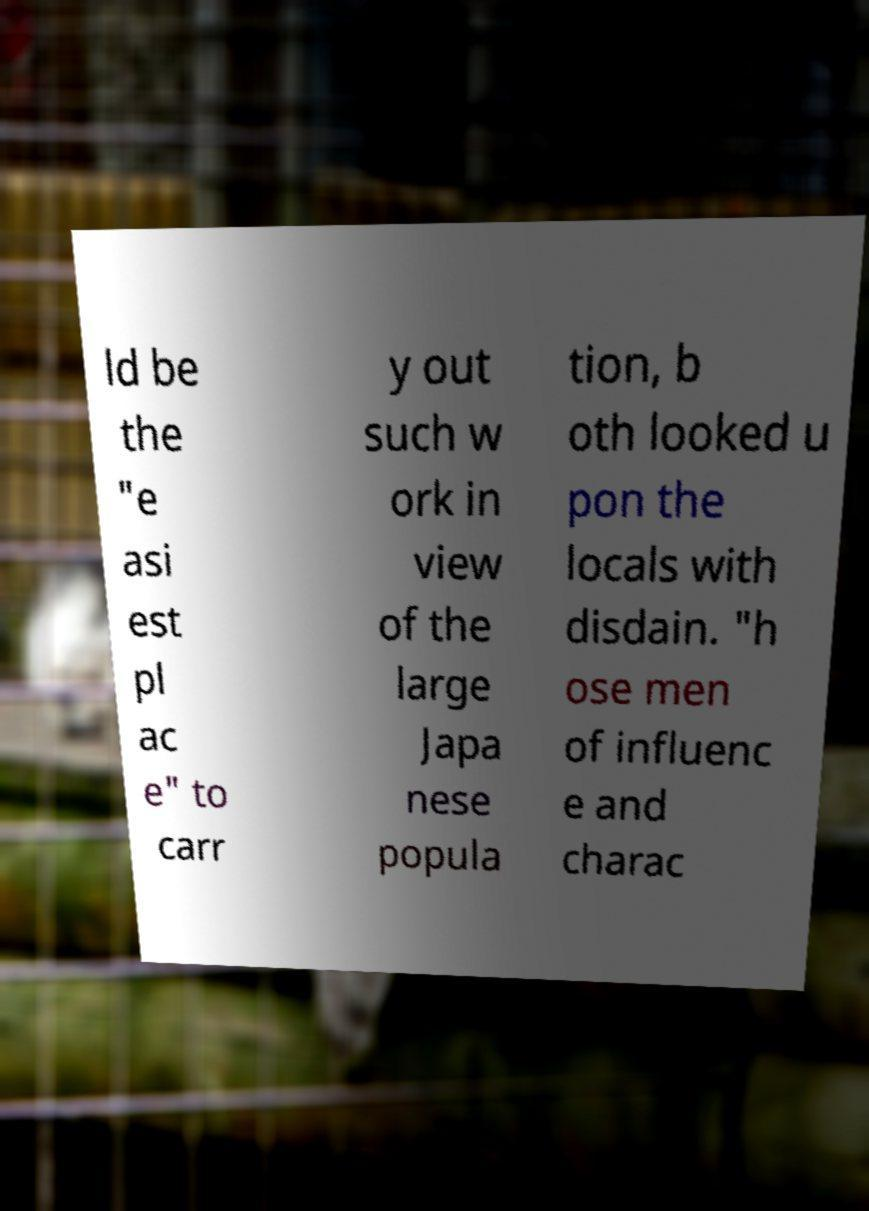Can you accurately transcribe the text from the provided image for me? ld be the "e asi est pl ac e" to carr y out such w ork in view of the large Japa nese popula tion, b oth looked u pon the locals with disdain. "h ose men of influenc e and charac 